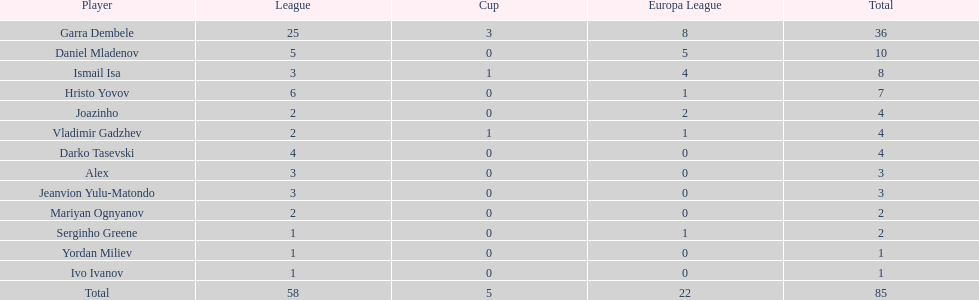Which player had the highest number of goals on this team? Garra Dembele. 